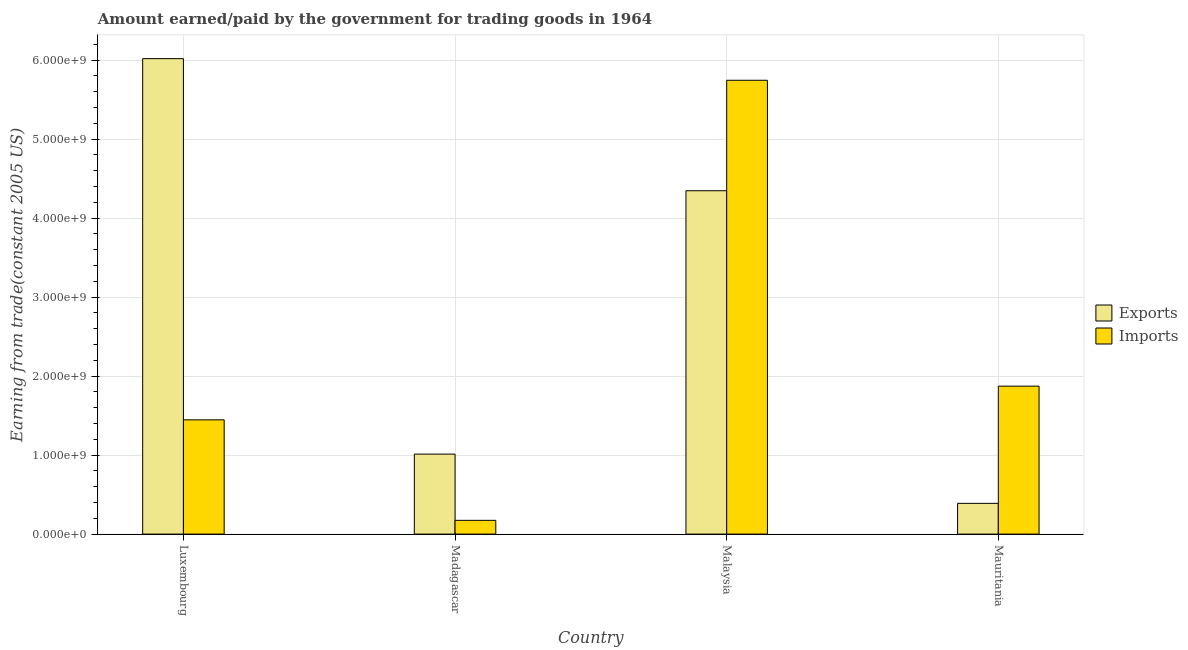How many groups of bars are there?
Provide a succinct answer. 4. How many bars are there on the 2nd tick from the left?
Provide a short and direct response. 2. How many bars are there on the 3rd tick from the right?
Your response must be concise. 2. What is the label of the 3rd group of bars from the left?
Offer a very short reply. Malaysia. What is the amount paid for imports in Madagascar?
Your answer should be compact. 1.74e+08. Across all countries, what is the maximum amount paid for imports?
Your answer should be compact. 5.75e+09. Across all countries, what is the minimum amount paid for imports?
Your response must be concise. 1.74e+08. In which country was the amount paid for imports maximum?
Give a very brief answer. Malaysia. In which country was the amount earned from exports minimum?
Offer a very short reply. Mauritania. What is the total amount earned from exports in the graph?
Give a very brief answer. 1.18e+1. What is the difference between the amount earned from exports in Luxembourg and that in Malaysia?
Your response must be concise. 1.67e+09. What is the difference between the amount earned from exports in Mauritania and the amount paid for imports in Luxembourg?
Provide a succinct answer. -1.06e+09. What is the average amount earned from exports per country?
Ensure brevity in your answer.  2.94e+09. What is the difference between the amount paid for imports and amount earned from exports in Mauritania?
Your answer should be compact. 1.48e+09. In how many countries, is the amount earned from exports greater than 5000000000 US$?
Give a very brief answer. 1. What is the ratio of the amount earned from exports in Malaysia to that in Mauritania?
Provide a short and direct response. 11.17. Is the amount earned from exports in Luxembourg less than that in Madagascar?
Your answer should be compact. No. Is the difference between the amount paid for imports in Madagascar and Malaysia greater than the difference between the amount earned from exports in Madagascar and Malaysia?
Keep it short and to the point. No. What is the difference between the highest and the second highest amount paid for imports?
Your answer should be very brief. 3.87e+09. What is the difference between the highest and the lowest amount paid for imports?
Provide a short and direct response. 5.57e+09. Is the sum of the amount earned from exports in Madagascar and Mauritania greater than the maximum amount paid for imports across all countries?
Your answer should be compact. No. What does the 2nd bar from the left in Malaysia represents?
Keep it short and to the point. Imports. What does the 2nd bar from the right in Luxembourg represents?
Your answer should be compact. Exports. How many bars are there?
Offer a terse response. 8. Are all the bars in the graph horizontal?
Provide a short and direct response. No. What is the difference between two consecutive major ticks on the Y-axis?
Your answer should be very brief. 1.00e+09. Are the values on the major ticks of Y-axis written in scientific E-notation?
Your answer should be compact. Yes. Where does the legend appear in the graph?
Offer a very short reply. Center right. How are the legend labels stacked?
Keep it short and to the point. Vertical. What is the title of the graph?
Provide a short and direct response. Amount earned/paid by the government for trading goods in 1964. Does "UN agencies" appear as one of the legend labels in the graph?
Make the answer very short. No. What is the label or title of the X-axis?
Your answer should be very brief. Country. What is the label or title of the Y-axis?
Your response must be concise. Earning from trade(constant 2005 US). What is the Earning from trade(constant 2005 US) in Exports in Luxembourg?
Provide a succinct answer. 6.02e+09. What is the Earning from trade(constant 2005 US) of Imports in Luxembourg?
Provide a short and direct response. 1.45e+09. What is the Earning from trade(constant 2005 US) in Exports in Madagascar?
Ensure brevity in your answer.  1.01e+09. What is the Earning from trade(constant 2005 US) in Imports in Madagascar?
Offer a terse response. 1.74e+08. What is the Earning from trade(constant 2005 US) of Exports in Malaysia?
Your answer should be compact. 4.35e+09. What is the Earning from trade(constant 2005 US) of Imports in Malaysia?
Offer a very short reply. 5.75e+09. What is the Earning from trade(constant 2005 US) of Exports in Mauritania?
Offer a very short reply. 3.89e+08. What is the Earning from trade(constant 2005 US) in Imports in Mauritania?
Provide a short and direct response. 1.87e+09. Across all countries, what is the maximum Earning from trade(constant 2005 US) in Exports?
Provide a succinct answer. 6.02e+09. Across all countries, what is the maximum Earning from trade(constant 2005 US) in Imports?
Your response must be concise. 5.75e+09. Across all countries, what is the minimum Earning from trade(constant 2005 US) in Exports?
Your answer should be compact. 3.89e+08. Across all countries, what is the minimum Earning from trade(constant 2005 US) of Imports?
Your response must be concise. 1.74e+08. What is the total Earning from trade(constant 2005 US) of Exports in the graph?
Ensure brevity in your answer.  1.18e+1. What is the total Earning from trade(constant 2005 US) of Imports in the graph?
Your answer should be compact. 9.24e+09. What is the difference between the Earning from trade(constant 2005 US) of Exports in Luxembourg and that in Madagascar?
Offer a very short reply. 5.01e+09. What is the difference between the Earning from trade(constant 2005 US) in Imports in Luxembourg and that in Madagascar?
Provide a short and direct response. 1.27e+09. What is the difference between the Earning from trade(constant 2005 US) of Exports in Luxembourg and that in Malaysia?
Keep it short and to the point. 1.67e+09. What is the difference between the Earning from trade(constant 2005 US) of Imports in Luxembourg and that in Malaysia?
Your response must be concise. -4.30e+09. What is the difference between the Earning from trade(constant 2005 US) in Exports in Luxembourg and that in Mauritania?
Your answer should be very brief. 5.63e+09. What is the difference between the Earning from trade(constant 2005 US) in Imports in Luxembourg and that in Mauritania?
Offer a terse response. -4.26e+08. What is the difference between the Earning from trade(constant 2005 US) of Exports in Madagascar and that in Malaysia?
Your response must be concise. -3.33e+09. What is the difference between the Earning from trade(constant 2005 US) of Imports in Madagascar and that in Malaysia?
Your answer should be compact. -5.57e+09. What is the difference between the Earning from trade(constant 2005 US) in Exports in Madagascar and that in Mauritania?
Keep it short and to the point. 6.24e+08. What is the difference between the Earning from trade(constant 2005 US) of Imports in Madagascar and that in Mauritania?
Your answer should be compact. -1.70e+09. What is the difference between the Earning from trade(constant 2005 US) in Exports in Malaysia and that in Mauritania?
Your answer should be compact. 3.96e+09. What is the difference between the Earning from trade(constant 2005 US) of Imports in Malaysia and that in Mauritania?
Give a very brief answer. 3.87e+09. What is the difference between the Earning from trade(constant 2005 US) in Exports in Luxembourg and the Earning from trade(constant 2005 US) in Imports in Madagascar?
Make the answer very short. 5.85e+09. What is the difference between the Earning from trade(constant 2005 US) of Exports in Luxembourg and the Earning from trade(constant 2005 US) of Imports in Malaysia?
Offer a very short reply. 2.74e+08. What is the difference between the Earning from trade(constant 2005 US) in Exports in Luxembourg and the Earning from trade(constant 2005 US) in Imports in Mauritania?
Give a very brief answer. 4.15e+09. What is the difference between the Earning from trade(constant 2005 US) of Exports in Madagascar and the Earning from trade(constant 2005 US) of Imports in Malaysia?
Your response must be concise. -4.73e+09. What is the difference between the Earning from trade(constant 2005 US) of Exports in Madagascar and the Earning from trade(constant 2005 US) of Imports in Mauritania?
Offer a terse response. -8.60e+08. What is the difference between the Earning from trade(constant 2005 US) in Exports in Malaysia and the Earning from trade(constant 2005 US) in Imports in Mauritania?
Give a very brief answer. 2.47e+09. What is the average Earning from trade(constant 2005 US) in Exports per country?
Give a very brief answer. 2.94e+09. What is the average Earning from trade(constant 2005 US) of Imports per country?
Your answer should be very brief. 2.31e+09. What is the difference between the Earning from trade(constant 2005 US) of Exports and Earning from trade(constant 2005 US) of Imports in Luxembourg?
Offer a terse response. 4.57e+09. What is the difference between the Earning from trade(constant 2005 US) in Exports and Earning from trade(constant 2005 US) in Imports in Madagascar?
Make the answer very short. 8.39e+08. What is the difference between the Earning from trade(constant 2005 US) in Exports and Earning from trade(constant 2005 US) in Imports in Malaysia?
Your answer should be compact. -1.40e+09. What is the difference between the Earning from trade(constant 2005 US) in Exports and Earning from trade(constant 2005 US) in Imports in Mauritania?
Your answer should be compact. -1.48e+09. What is the ratio of the Earning from trade(constant 2005 US) in Exports in Luxembourg to that in Madagascar?
Give a very brief answer. 5.94. What is the ratio of the Earning from trade(constant 2005 US) in Imports in Luxembourg to that in Madagascar?
Ensure brevity in your answer.  8.3. What is the ratio of the Earning from trade(constant 2005 US) in Exports in Luxembourg to that in Malaysia?
Your answer should be compact. 1.38. What is the ratio of the Earning from trade(constant 2005 US) of Imports in Luxembourg to that in Malaysia?
Give a very brief answer. 0.25. What is the ratio of the Earning from trade(constant 2005 US) of Exports in Luxembourg to that in Mauritania?
Your answer should be compact. 15.46. What is the ratio of the Earning from trade(constant 2005 US) in Imports in Luxembourg to that in Mauritania?
Provide a short and direct response. 0.77. What is the ratio of the Earning from trade(constant 2005 US) of Exports in Madagascar to that in Malaysia?
Make the answer very short. 0.23. What is the ratio of the Earning from trade(constant 2005 US) of Imports in Madagascar to that in Malaysia?
Your response must be concise. 0.03. What is the ratio of the Earning from trade(constant 2005 US) in Exports in Madagascar to that in Mauritania?
Your answer should be very brief. 2.6. What is the ratio of the Earning from trade(constant 2005 US) in Imports in Madagascar to that in Mauritania?
Provide a short and direct response. 0.09. What is the ratio of the Earning from trade(constant 2005 US) of Exports in Malaysia to that in Mauritania?
Provide a short and direct response. 11.17. What is the ratio of the Earning from trade(constant 2005 US) of Imports in Malaysia to that in Mauritania?
Offer a terse response. 3.07. What is the difference between the highest and the second highest Earning from trade(constant 2005 US) in Exports?
Offer a terse response. 1.67e+09. What is the difference between the highest and the second highest Earning from trade(constant 2005 US) of Imports?
Your answer should be very brief. 3.87e+09. What is the difference between the highest and the lowest Earning from trade(constant 2005 US) in Exports?
Give a very brief answer. 5.63e+09. What is the difference between the highest and the lowest Earning from trade(constant 2005 US) in Imports?
Offer a very short reply. 5.57e+09. 